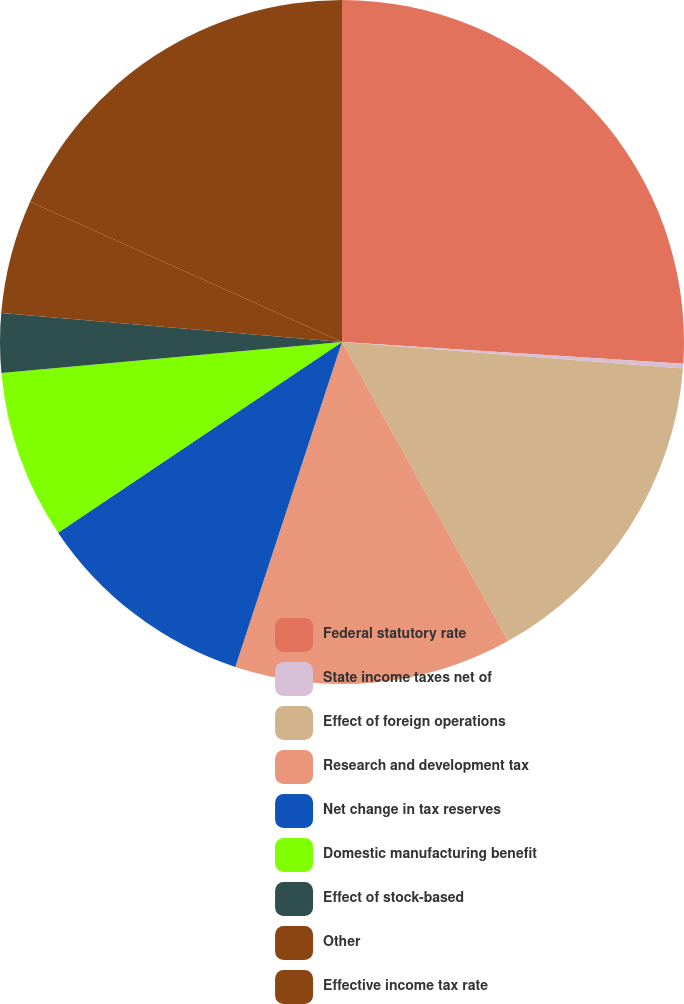Convert chart. <chart><loc_0><loc_0><loc_500><loc_500><pie_chart><fcel>Federal statutory rate<fcel>State income taxes net of<fcel>Effect of foreign operations<fcel>Research and development tax<fcel>Net change in tax reserves<fcel>Domestic manufacturing benefit<fcel>Effect of stock-based<fcel>Other<fcel>Effective income tax rate<nl><fcel>26.01%<fcel>0.22%<fcel>15.7%<fcel>13.12%<fcel>10.54%<fcel>7.96%<fcel>2.8%<fcel>5.38%<fcel>18.27%<nl></chart> 